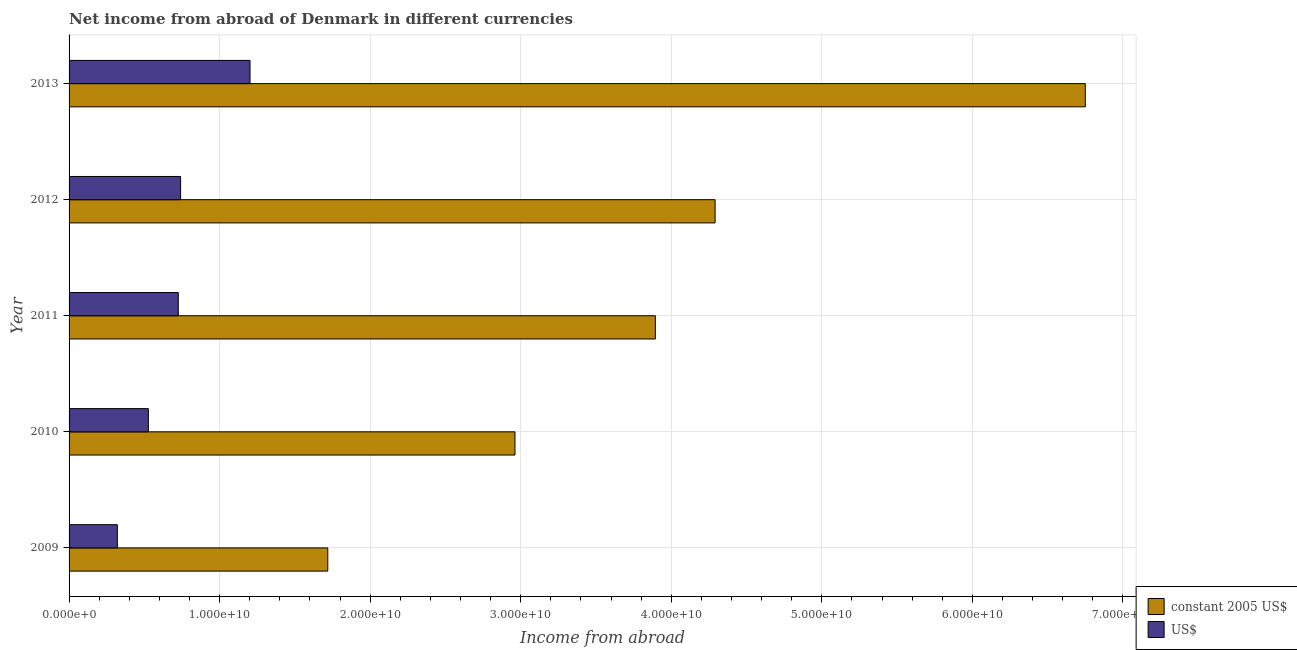How many different coloured bars are there?
Offer a very short reply. 2. Are the number of bars per tick equal to the number of legend labels?
Keep it short and to the point. Yes. How many bars are there on the 2nd tick from the top?
Provide a short and direct response. 2. How many bars are there on the 4th tick from the bottom?
Your answer should be very brief. 2. What is the label of the 2nd group of bars from the top?
Your answer should be compact. 2012. In how many cases, is the number of bars for a given year not equal to the number of legend labels?
Provide a short and direct response. 0. What is the income from abroad in constant 2005 us$ in 2009?
Keep it short and to the point. 1.72e+1. Across all years, what is the maximum income from abroad in constant 2005 us$?
Provide a succinct answer. 6.75e+1. Across all years, what is the minimum income from abroad in constant 2005 us$?
Offer a very short reply. 1.72e+1. In which year was the income from abroad in constant 2005 us$ minimum?
Your answer should be compact. 2009. What is the total income from abroad in us$ in the graph?
Your response must be concise. 3.52e+1. What is the difference between the income from abroad in us$ in 2010 and that in 2011?
Keep it short and to the point. -1.99e+09. What is the difference between the income from abroad in constant 2005 us$ in 2009 and the income from abroad in us$ in 2012?
Provide a short and direct response. 9.78e+09. What is the average income from abroad in us$ per year?
Keep it short and to the point. 7.03e+09. In the year 2011, what is the difference between the income from abroad in constant 2005 us$ and income from abroad in us$?
Ensure brevity in your answer.  3.17e+1. What is the ratio of the income from abroad in constant 2005 us$ in 2009 to that in 2012?
Make the answer very short. 0.4. Is the difference between the income from abroad in us$ in 2010 and 2013 greater than the difference between the income from abroad in constant 2005 us$ in 2010 and 2013?
Provide a succinct answer. Yes. What is the difference between the highest and the second highest income from abroad in us$?
Your answer should be compact. 4.61e+09. What is the difference between the highest and the lowest income from abroad in us$?
Provide a short and direct response. 8.81e+09. In how many years, is the income from abroad in constant 2005 us$ greater than the average income from abroad in constant 2005 us$ taken over all years?
Your answer should be very brief. 2. What does the 1st bar from the top in 2011 represents?
Provide a succinct answer. US$. What does the 1st bar from the bottom in 2013 represents?
Provide a succinct answer. Constant 2005 us$. How many bars are there?
Provide a succinct answer. 10. Are all the bars in the graph horizontal?
Provide a succinct answer. Yes. How many years are there in the graph?
Keep it short and to the point. 5. What is the difference between two consecutive major ticks on the X-axis?
Keep it short and to the point. 1.00e+1. Does the graph contain any zero values?
Provide a succinct answer. No. Does the graph contain grids?
Your response must be concise. Yes. Where does the legend appear in the graph?
Give a very brief answer. Bottom right. How are the legend labels stacked?
Your answer should be compact. Vertical. What is the title of the graph?
Offer a very short reply. Net income from abroad of Denmark in different currencies. Does "Girls" appear as one of the legend labels in the graph?
Your answer should be very brief. No. What is the label or title of the X-axis?
Keep it short and to the point. Income from abroad. What is the Income from abroad in constant 2005 US$ in 2009?
Your response must be concise. 1.72e+1. What is the Income from abroad of US$ in 2009?
Ensure brevity in your answer.  3.21e+09. What is the Income from abroad of constant 2005 US$ in 2010?
Your response must be concise. 2.96e+1. What is the Income from abroad of US$ in 2010?
Keep it short and to the point. 5.27e+09. What is the Income from abroad of constant 2005 US$ in 2011?
Give a very brief answer. 3.89e+1. What is the Income from abroad in US$ in 2011?
Provide a short and direct response. 7.25e+09. What is the Income from abroad of constant 2005 US$ in 2012?
Offer a terse response. 4.29e+1. What is the Income from abroad of US$ in 2012?
Your response must be concise. 7.41e+09. What is the Income from abroad of constant 2005 US$ in 2013?
Keep it short and to the point. 6.75e+1. What is the Income from abroad of US$ in 2013?
Your response must be concise. 1.20e+1. Across all years, what is the maximum Income from abroad of constant 2005 US$?
Your answer should be compact. 6.75e+1. Across all years, what is the maximum Income from abroad in US$?
Keep it short and to the point. 1.20e+1. Across all years, what is the minimum Income from abroad of constant 2005 US$?
Your answer should be compact. 1.72e+1. Across all years, what is the minimum Income from abroad in US$?
Keep it short and to the point. 3.21e+09. What is the total Income from abroad of constant 2005 US$ in the graph?
Make the answer very short. 1.96e+11. What is the total Income from abroad of US$ in the graph?
Provide a succinct answer. 3.52e+1. What is the difference between the Income from abroad in constant 2005 US$ in 2009 and that in 2010?
Provide a succinct answer. -1.24e+1. What is the difference between the Income from abroad in US$ in 2009 and that in 2010?
Your answer should be compact. -2.06e+09. What is the difference between the Income from abroad in constant 2005 US$ in 2009 and that in 2011?
Provide a succinct answer. -2.18e+1. What is the difference between the Income from abroad in US$ in 2009 and that in 2011?
Provide a succinct answer. -4.05e+09. What is the difference between the Income from abroad in constant 2005 US$ in 2009 and that in 2012?
Give a very brief answer. -2.57e+1. What is the difference between the Income from abroad of US$ in 2009 and that in 2012?
Offer a very short reply. -4.20e+09. What is the difference between the Income from abroad of constant 2005 US$ in 2009 and that in 2013?
Keep it short and to the point. -5.03e+1. What is the difference between the Income from abroad in US$ in 2009 and that in 2013?
Offer a terse response. -8.81e+09. What is the difference between the Income from abroad in constant 2005 US$ in 2010 and that in 2011?
Provide a short and direct response. -9.33e+09. What is the difference between the Income from abroad of US$ in 2010 and that in 2011?
Offer a very short reply. -1.99e+09. What is the difference between the Income from abroad in constant 2005 US$ in 2010 and that in 2012?
Offer a terse response. -1.33e+1. What is the difference between the Income from abroad in US$ in 2010 and that in 2012?
Give a very brief answer. -2.14e+09. What is the difference between the Income from abroad in constant 2005 US$ in 2010 and that in 2013?
Keep it short and to the point. -3.79e+1. What is the difference between the Income from abroad in US$ in 2010 and that in 2013?
Offer a terse response. -6.75e+09. What is the difference between the Income from abroad in constant 2005 US$ in 2011 and that in 2012?
Your answer should be very brief. -3.97e+09. What is the difference between the Income from abroad of US$ in 2011 and that in 2012?
Make the answer very short. -1.54e+08. What is the difference between the Income from abroad of constant 2005 US$ in 2011 and that in 2013?
Offer a very short reply. -2.86e+1. What is the difference between the Income from abroad in US$ in 2011 and that in 2013?
Give a very brief answer. -4.77e+09. What is the difference between the Income from abroad in constant 2005 US$ in 2012 and that in 2013?
Offer a very short reply. -2.46e+1. What is the difference between the Income from abroad in US$ in 2012 and that in 2013?
Make the answer very short. -4.61e+09. What is the difference between the Income from abroad of constant 2005 US$ in 2009 and the Income from abroad of US$ in 2010?
Your response must be concise. 1.19e+1. What is the difference between the Income from abroad in constant 2005 US$ in 2009 and the Income from abroad in US$ in 2011?
Your answer should be very brief. 9.93e+09. What is the difference between the Income from abroad in constant 2005 US$ in 2009 and the Income from abroad in US$ in 2012?
Your answer should be compact. 9.78e+09. What is the difference between the Income from abroad of constant 2005 US$ in 2009 and the Income from abroad of US$ in 2013?
Your answer should be compact. 5.17e+09. What is the difference between the Income from abroad of constant 2005 US$ in 2010 and the Income from abroad of US$ in 2011?
Offer a very short reply. 2.24e+1. What is the difference between the Income from abroad of constant 2005 US$ in 2010 and the Income from abroad of US$ in 2012?
Your response must be concise. 2.22e+1. What is the difference between the Income from abroad in constant 2005 US$ in 2010 and the Income from abroad in US$ in 2013?
Offer a terse response. 1.76e+1. What is the difference between the Income from abroad of constant 2005 US$ in 2011 and the Income from abroad of US$ in 2012?
Provide a succinct answer. 3.15e+1. What is the difference between the Income from abroad of constant 2005 US$ in 2011 and the Income from abroad of US$ in 2013?
Your response must be concise. 2.69e+1. What is the difference between the Income from abroad of constant 2005 US$ in 2012 and the Income from abroad of US$ in 2013?
Provide a succinct answer. 3.09e+1. What is the average Income from abroad in constant 2005 US$ per year?
Make the answer very short. 3.92e+1. What is the average Income from abroad of US$ per year?
Make the answer very short. 7.03e+09. In the year 2009, what is the difference between the Income from abroad of constant 2005 US$ and Income from abroad of US$?
Offer a terse response. 1.40e+1. In the year 2010, what is the difference between the Income from abroad of constant 2005 US$ and Income from abroad of US$?
Your answer should be compact. 2.44e+1. In the year 2011, what is the difference between the Income from abroad of constant 2005 US$ and Income from abroad of US$?
Ensure brevity in your answer.  3.17e+1. In the year 2012, what is the difference between the Income from abroad in constant 2005 US$ and Income from abroad in US$?
Your response must be concise. 3.55e+1. In the year 2013, what is the difference between the Income from abroad in constant 2005 US$ and Income from abroad in US$?
Keep it short and to the point. 5.55e+1. What is the ratio of the Income from abroad in constant 2005 US$ in 2009 to that in 2010?
Offer a terse response. 0.58. What is the ratio of the Income from abroad of US$ in 2009 to that in 2010?
Give a very brief answer. 0.61. What is the ratio of the Income from abroad of constant 2005 US$ in 2009 to that in 2011?
Offer a very short reply. 0.44. What is the ratio of the Income from abroad in US$ in 2009 to that in 2011?
Offer a terse response. 0.44. What is the ratio of the Income from abroad of constant 2005 US$ in 2009 to that in 2012?
Keep it short and to the point. 0.4. What is the ratio of the Income from abroad of US$ in 2009 to that in 2012?
Your response must be concise. 0.43. What is the ratio of the Income from abroad of constant 2005 US$ in 2009 to that in 2013?
Offer a very short reply. 0.25. What is the ratio of the Income from abroad of US$ in 2009 to that in 2013?
Ensure brevity in your answer.  0.27. What is the ratio of the Income from abroad in constant 2005 US$ in 2010 to that in 2011?
Provide a succinct answer. 0.76. What is the ratio of the Income from abroad in US$ in 2010 to that in 2011?
Your response must be concise. 0.73. What is the ratio of the Income from abroad of constant 2005 US$ in 2010 to that in 2012?
Your response must be concise. 0.69. What is the ratio of the Income from abroad of US$ in 2010 to that in 2012?
Make the answer very short. 0.71. What is the ratio of the Income from abroad of constant 2005 US$ in 2010 to that in 2013?
Provide a short and direct response. 0.44. What is the ratio of the Income from abroad of US$ in 2010 to that in 2013?
Give a very brief answer. 0.44. What is the ratio of the Income from abroad in constant 2005 US$ in 2011 to that in 2012?
Provide a succinct answer. 0.91. What is the ratio of the Income from abroad of US$ in 2011 to that in 2012?
Provide a short and direct response. 0.98. What is the ratio of the Income from abroad of constant 2005 US$ in 2011 to that in 2013?
Provide a succinct answer. 0.58. What is the ratio of the Income from abroad in US$ in 2011 to that in 2013?
Offer a terse response. 0.6. What is the ratio of the Income from abroad in constant 2005 US$ in 2012 to that in 2013?
Ensure brevity in your answer.  0.64. What is the ratio of the Income from abroad of US$ in 2012 to that in 2013?
Keep it short and to the point. 0.62. What is the difference between the highest and the second highest Income from abroad of constant 2005 US$?
Your response must be concise. 2.46e+1. What is the difference between the highest and the second highest Income from abroad in US$?
Your answer should be compact. 4.61e+09. What is the difference between the highest and the lowest Income from abroad of constant 2005 US$?
Provide a short and direct response. 5.03e+1. What is the difference between the highest and the lowest Income from abroad of US$?
Your answer should be compact. 8.81e+09. 